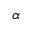<formula> <loc_0><loc_0><loc_500><loc_500>\alpha</formula> 